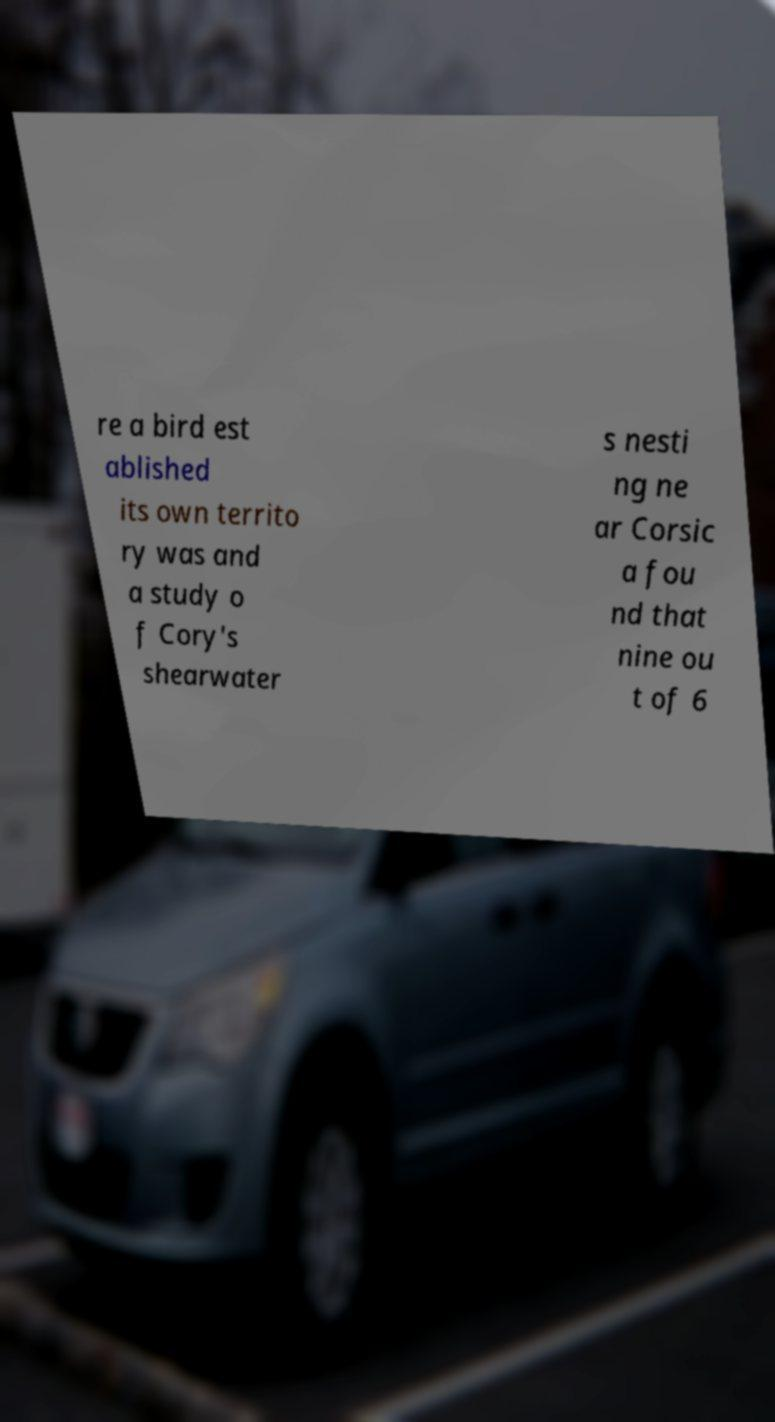What messages or text are displayed in this image? I need them in a readable, typed format. re a bird est ablished its own territo ry was and a study o f Cory's shearwater s nesti ng ne ar Corsic a fou nd that nine ou t of 6 